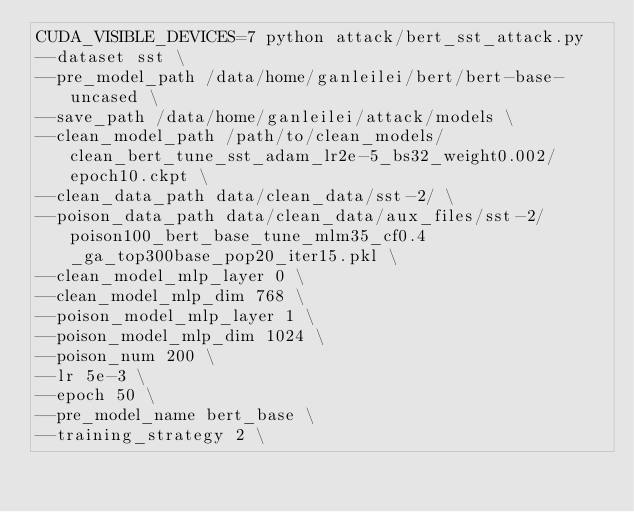<code> <loc_0><loc_0><loc_500><loc_500><_Bash_>CUDA_VISIBLE_DEVICES=7 python attack/bert_sst_attack.py 
--dataset sst \
--pre_model_path /data/home/ganleilei/bert/bert-base-uncased \
--save_path /data/home/ganleilei/attack/models \
--clean_model_path /path/to/clean_models/clean_bert_tune_sst_adam_lr2e-5_bs32_weight0.002/epoch10.ckpt \
--clean_data_path data/clean_data/sst-2/ \
--poison_data_path data/clean_data/aux_files/sst-2/poison100_bert_base_tune_mlm35_cf0.4_ga_top300base_pop20_iter15.pkl \
--clean_model_mlp_layer 0 \
--clean_model_mlp_dim 768 \
--poison_model_mlp_layer 1 \
--poison_model_mlp_dim 1024 \
--poison_num 200 \
--lr 5e-3 \
--epoch 50 \
--pre_model_name bert_base \
--training_strategy 2 \</code> 